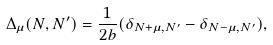<formula> <loc_0><loc_0><loc_500><loc_500>\Delta _ { \mu } ( N , N ^ { \prime } ) = \frac { 1 } { 2 b } ( \delta _ { N + \mu , N ^ { \prime } } - \delta _ { N - \mu , N ^ { \prime } } ) ,</formula> 